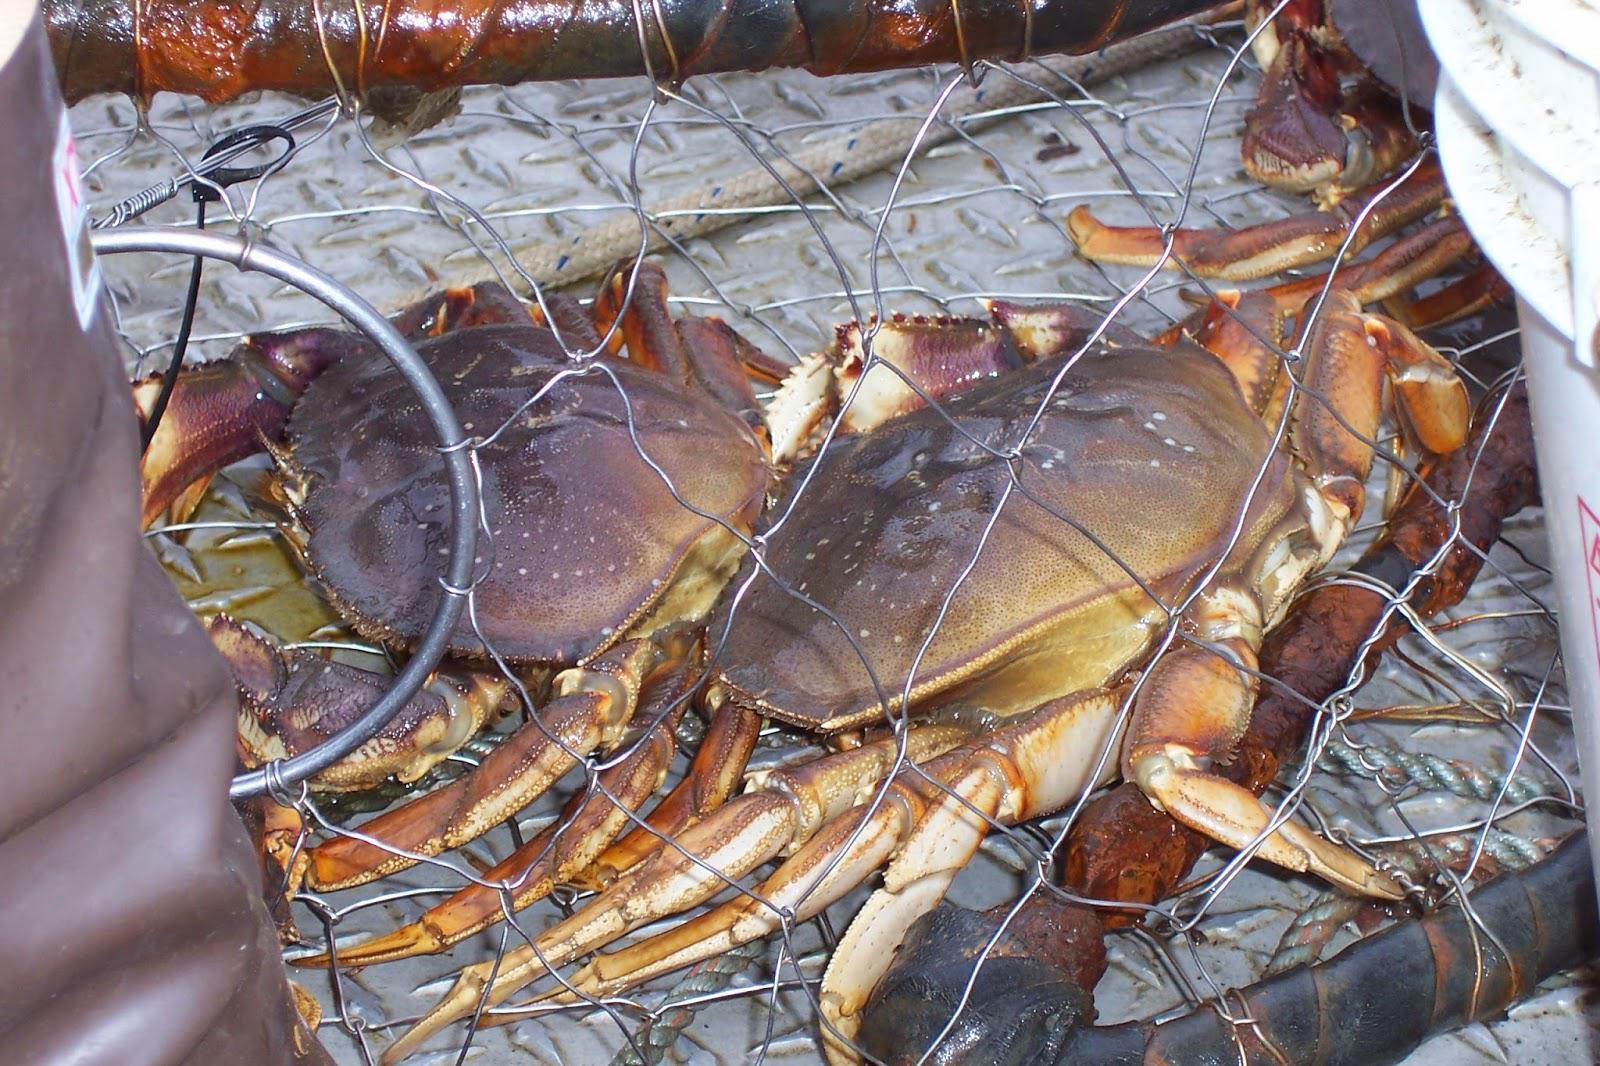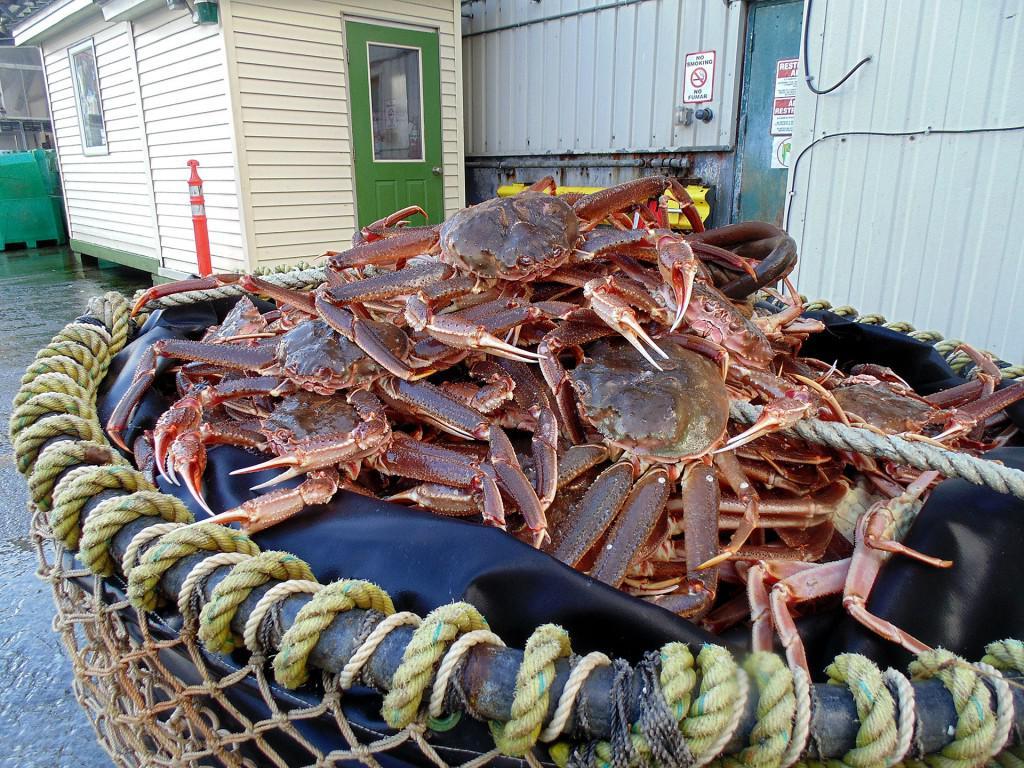The first image is the image on the left, the second image is the image on the right. Evaluate the accuracy of this statement regarding the images: "Each image shows purplish-gray crabs in a container made of mesh attached to a frame.". Is it true? Answer yes or no. Yes. The first image is the image on the left, the second image is the image on the right. Given the left and right images, does the statement "At least one crab is in the wild." hold true? Answer yes or no. No. 